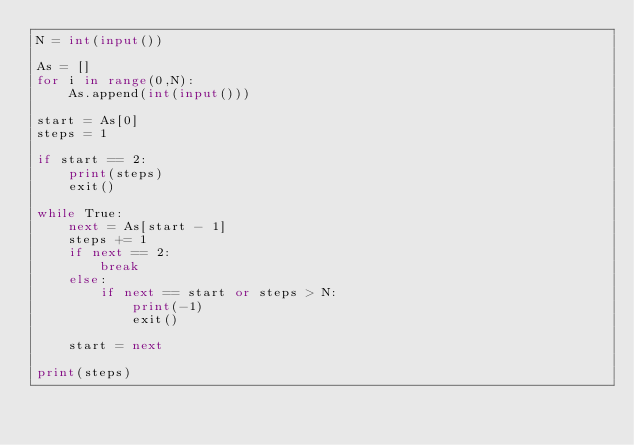<code> <loc_0><loc_0><loc_500><loc_500><_Python_>N = int(input())

As = []
for i in range(0,N):
    As.append(int(input()))

start = As[0]
steps = 1

if start == 2:
    print(steps)
    exit()

while True:
    next = As[start - 1]
    steps += 1
    if next == 2:
        break
    else:
        if next == start or steps > N:
            print(-1)
            exit()

    start = next

print(steps)</code> 